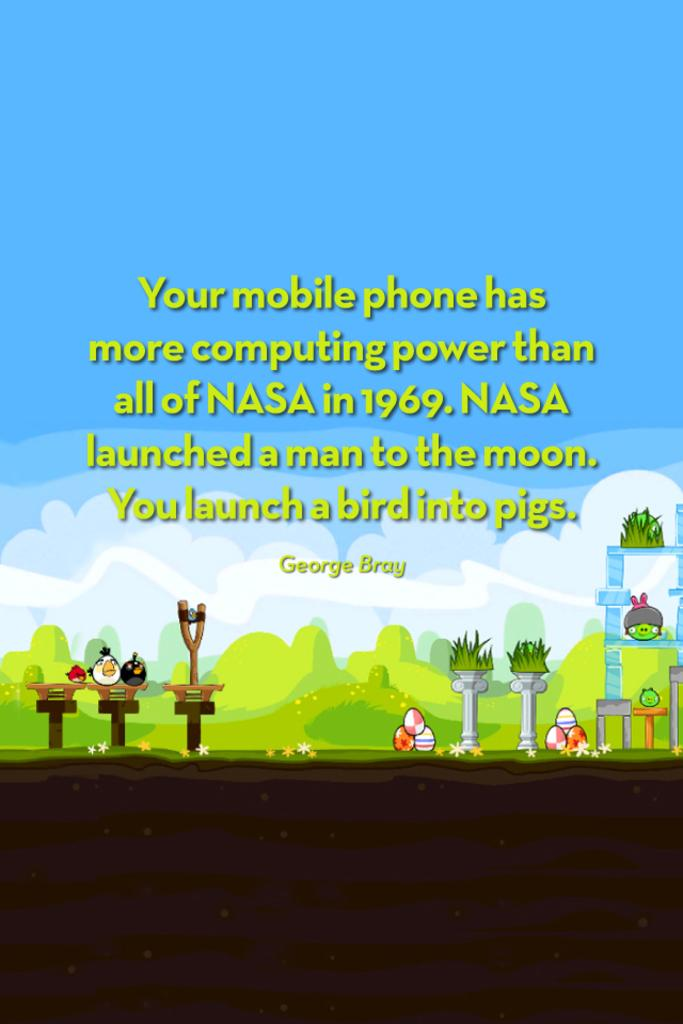<image>
Render a clear and concise summary of the photo. A quote by George Bray begins with "your mobile phone." 